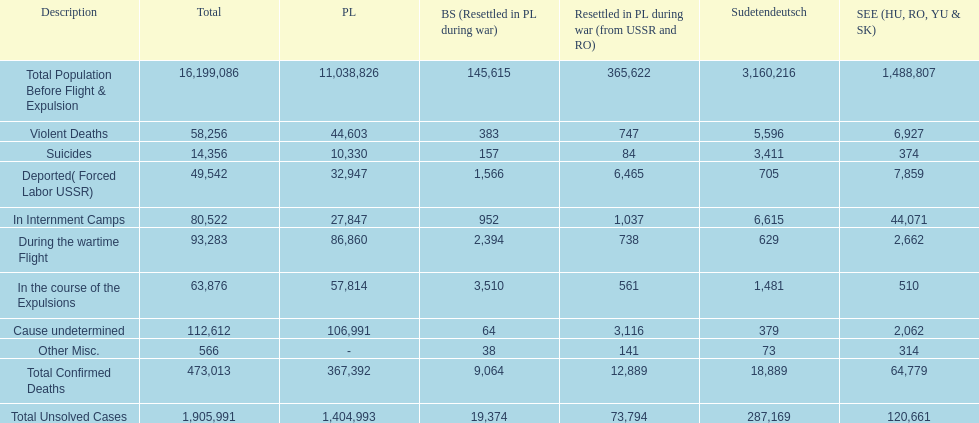Did any location have no violent deaths? No. 